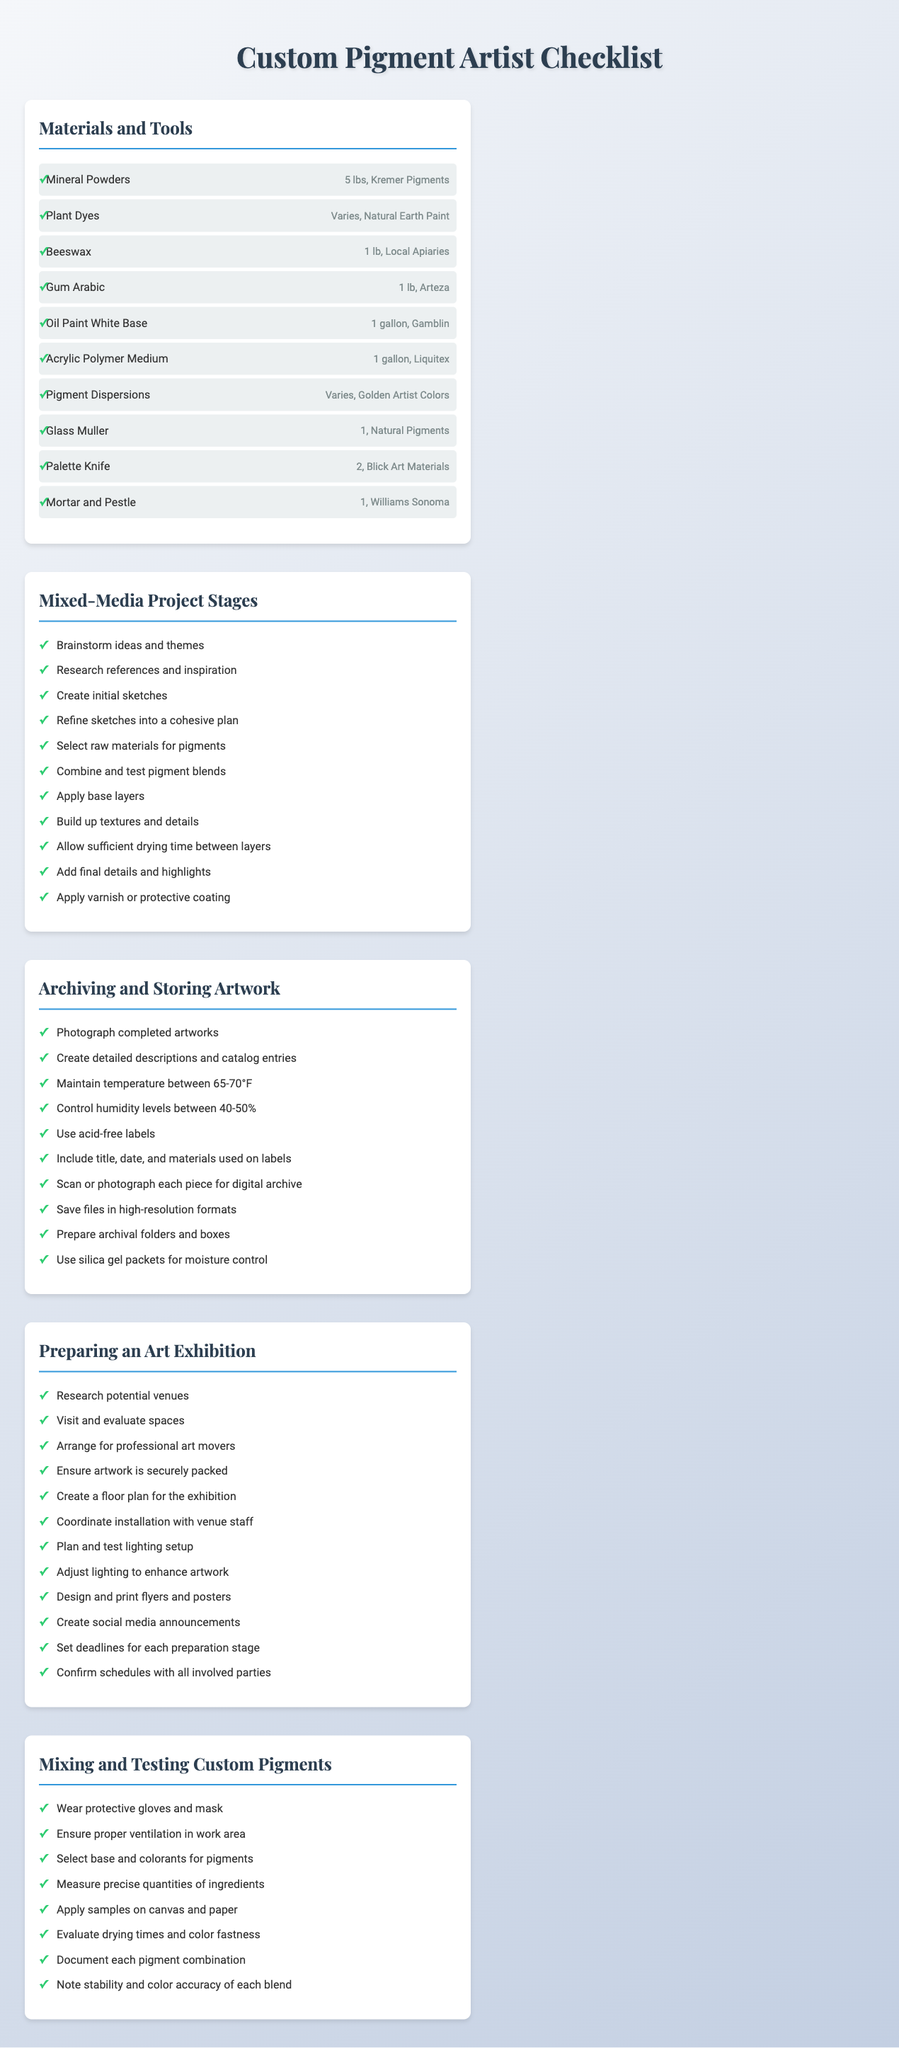what is the total weight of mineral powders needed? The total weight required for mineral powders is specified as 5 lbs in the materials checklist.
Answer: 5 lbs where can you purchase beeswax? The supplier information for beeswax indicates it can be purchased from local apiaries.
Answer: Local Apiaries how many steps are there in the Mixed-Media Project Stages? The Mixed-Media Project Stages checklist consists of 11 steps.
Answer: 11 what is the recommended humidity level for storing artwork? The checklist states the recommended humidity levels for storage should be between 40-50%.
Answer: 40-50% which tool is used for mixing and testing pigments? A glass muller is listed as a tool for mixing and testing pigments.
Answer: Glass Muller what is the first task in preparing an art exhibition? The first task listed is researching potential venues.
Answer: Research potential venues how should the final details of the artwork be applied? The final details and highlights should be added according to the Mixed-Media Project Stages checklist.
Answer: Add final details and highlights what safety equipment is recommended for mixing pigments? The document advises wearing protective gloves and a mask when mixing pigments.
Answer: Gloves and mask how many types of custom pigments are listed? The materials checklist mentions two types: mineral powders and plant dyes.
Answer: Two types 